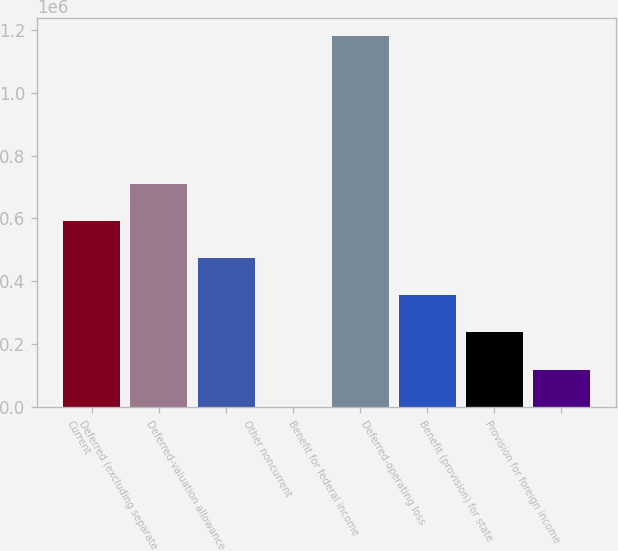<chart> <loc_0><loc_0><loc_500><loc_500><bar_chart><fcel>Current<fcel>Deferred (excluding separate<fcel>Deferred-valuation allowance<fcel>Other noncurrent<fcel>Benefit for federal income<fcel>Deferred-operating loss<fcel>Benefit (provision) for state<fcel>Provision for foreign income<nl><fcel>590549<fcel>708388<fcel>472710<fcel>1356<fcel>1.17974e+06<fcel>354872<fcel>237033<fcel>119195<nl></chart> 